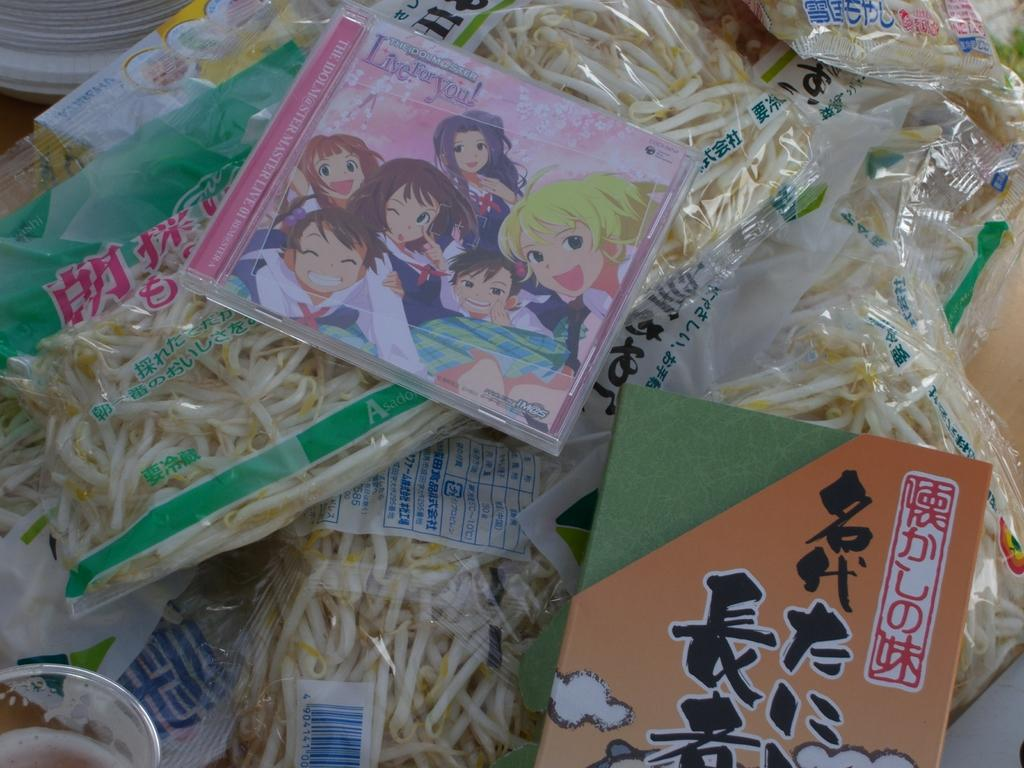What type of items can be seen in the image? There are food packets and a DVD box in the image. What is depicted on the DVD box? Cartoon characters are present on the DVD box. What type of teeth can be seen on the food packets in the image? There are no teeth present on the food packets in the image. 